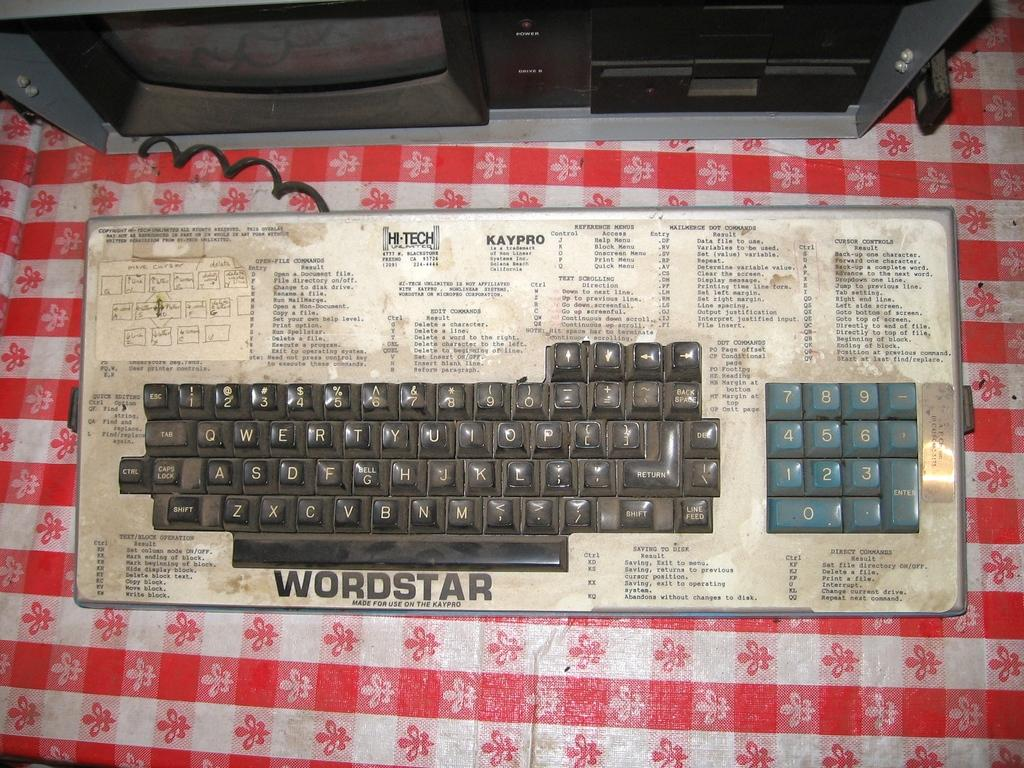<image>
Give a short and clear explanation of the subsequent image. a very old looking keyboard with the word WORDSTAR on the bottom 